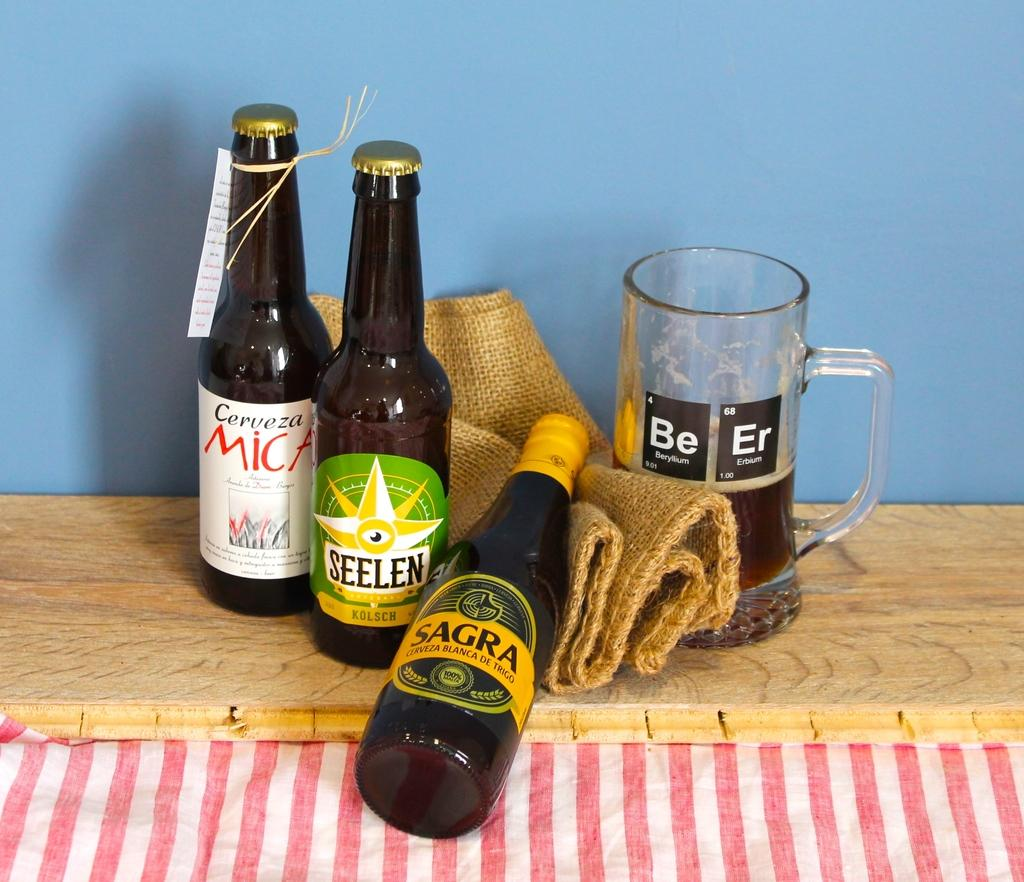How many beer bottles are visible in the image? There are three beer bottles in the image. What other type of container for beer is present in the image? There is one beer glass in the image. What type of bag is present in the image? There is a jute bag in the image. Where are all these objects placed in the image? All of these objects are on a wooden plank. What color is the background of the image? The background of the image is blue in color. Can you see any dirt on the wooden plank in the image? There is no dirt visible on the wooden plank in the image. What type of soda is being served in the beer glass? The image only shows beer bottles and a beer glass, so there is no soda present. 